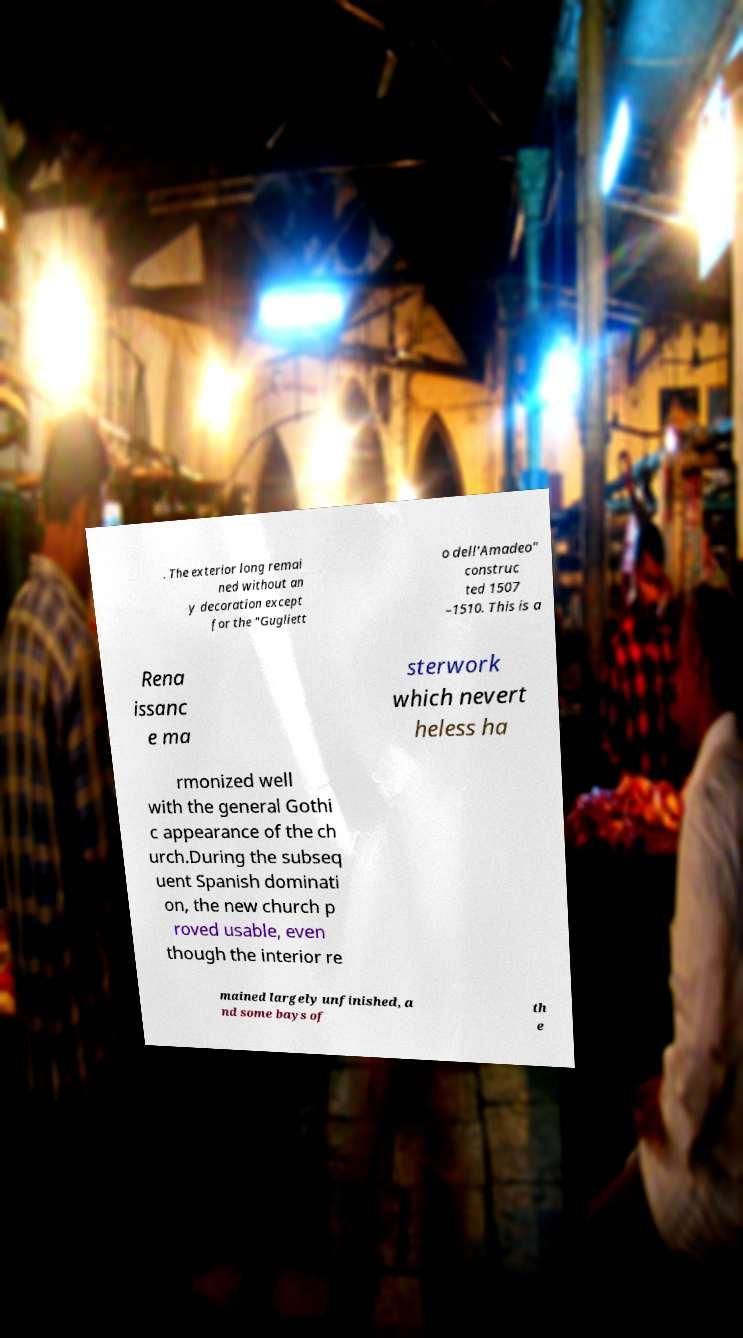Please identify and transcribe the text found in this image. . The exterior long remai ned without an y decoration except for the "Gugliett o dell'Amadeo" construc ted 1507 –1510. This is a Rena issanc e ma sterwork which nevert heless ha rmonized well with the general Gothi c appearance of the ch urch.During the subseq uent Spanish dominati on, the new church p roved usable, even though the interior re mained largely unfinished, a nd some bays of th e 